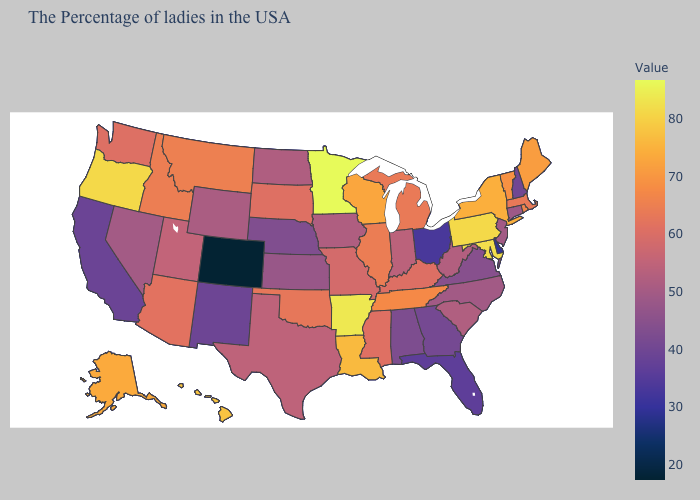Does Colorado have the lowest value in the West?
Concise answer only. Yes. Among the states that border Massachusetts , does New Hampshire have the lowest value?
Keep it brief. Yes. 